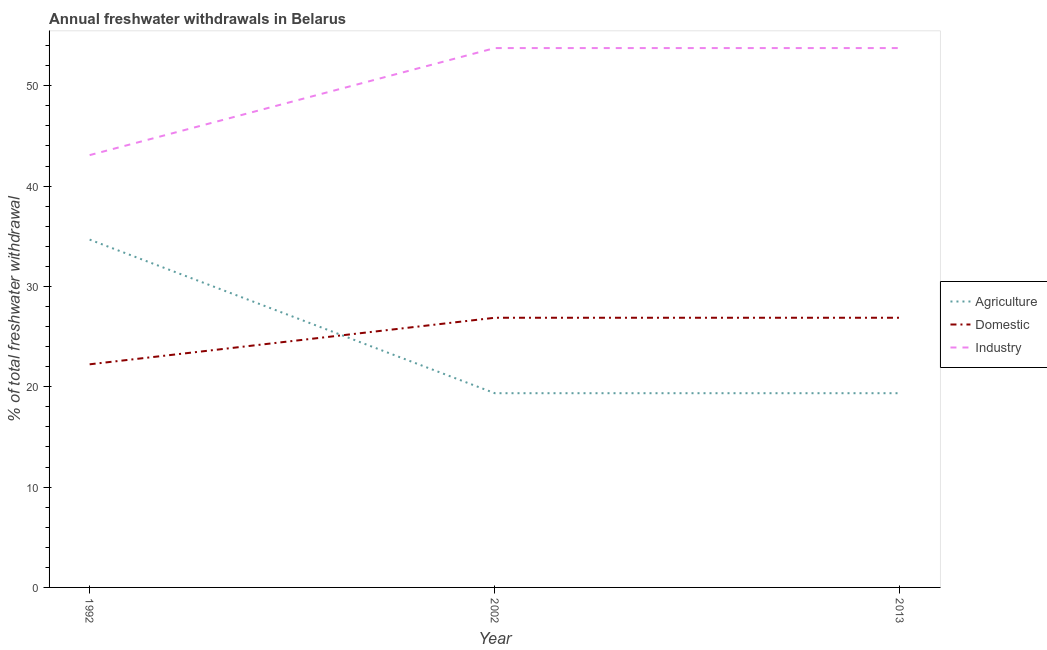How many different coloured lines are there?
Make the answer very short. 3. Does the line corresponding to percentage of freshwater withdrawal for industry intersect with the line corresponding to percentage of freshwater withdrawal for agriculture?
Provide a succinct answer. No. Is the number of lines equal to the number of legend labels?
Provide a short and direct response. Yes. What is the percentage of freshwater withdrawal for domestic purposes in 2002?
Your response must be concise. 26.88. Across all years, what is the maximum percentage of freshwater withdrawal for agriculture?
Ensure brevity in your answer.  34.67. Across all years, what is the minimum percentage of freshwater withdrawal for industry?
Offer a terse response. 43.09. What is the total percentage of freshwater withdrawal for domestic purposes in the graph?
Your response must be concise. 76. What is the difference between the percentage of freshwater withdrawal for industry in 1992 and that in 2002?
Provide a short and direct response. -10.67. What is the difference between the percentage of freshwater withdrawal for agriculture in 2013 and the percentage of freshwater withdrawal for domestic purposes in 2002?
Provide a short and direct response. -7.52. What is the average percentage of freshwater withdrawal for domestic purposes per year?
Provide a succinct answer. 25.33. In the year 1992, what is the difference between the percentage of freshwater withdrawal for domestic purposes and percentage of freshwater withdrawal for agriculture?
Provide a succinct answer. -12.43. In how many years, is the percentage of freshwater withdrawal for agriculture greater than 26 %?
Your response must be concise. 1. What is the ratio of the percentage of freshwater withdrawal for agriculture in 1992 to that in 2002?
Give a very brief answer. 1.79. Is the percentage of freshwater withdrawal for industry in 2002 less than that in 2013?
Give a very brief answer. No. What is the difference between the highest and the lowest percentage of freshwater withdrawal for agriculture?
Offer a very short reply. 15.31. In how many years, is the percentage of freshwater withdrawal for industry greater than the average percentage of freshwater withdrawal for industry taken over all years?
Your response must be concise. 2. Is the sum of the percentage of freshwater withdrawal for agriculture in 2002 and 2013 greater than the maximum percentage of freshwater withdrawal for industry across all years?
Ensure brevity in your answer.  No. Is the percentage of freshwater withdrawal for industry strictly less than the percentage of freshwater withdrawal for domestic purposes over the years?
Keep it short and to the point. No. How many years are there in the graph?
Your response must be concise. 3. Are the values on the major ticks of Y-axis written in scientific E-notation?
Provide a short and direct response. No. Does the graph contain grids?
Your response must be concise. No. How many legend labels are there?
Offer a very short reply. 3. What is the title of the graph?
Make the answer very short. Annual freshwater withdrawals in Belarus. Does "Argument" appear as one of the legend labels in the graph?
Offer a terse response. No. What is the label or title of the X-axis?
Your answer should be compact. Year. What is the label or title of the Y-axis?
Keep it short and to the point. % of total freshwater withdrawal. What is the % of total freshwater withdrawal in Agriculture in 1992?
Make the answer very short. 34.67. What is the % of total freshwater withdrawal of Domestic in 1992?
Ensure brevity in your answer.  22.24. What is the % of total freshwater withdrawal in Industry in 1992?
Offer a very short reply. 43.09. What is the % of total freshwater withdrawal in Agriculture in 2002?
Your answer should be compact. 19.36. What is the % of total freshwater withdrawal in Domestic in 2002?
Give a very brief answer. 26.88. What is the % of total freshwater withdrawal in Industry in 2002?
Make the answer very short. 53.76. What is the % of total freshwater withdrawal in Agriculture in 2013?
Your answer should be very brief. 19.36. What is the % of total freshwater withdrawal of Domestic in 2013?
Your answer should be very brief. 26.88. What is the % of total freshwater withdrawal in Industry in 2013?
Your answer should be very brief. 53.76. Across all years, what is the maximum % of total freshwater withdrawal of Agriculture?
Your answer should be very brief. 34.67. Across all years, what is the maximum % of total freshwater withdrawal in Domestic?
Offer a very short reply. 26.88. Across all years, what is the maximum % of total freshwater withdrawal in Industry?
Give a very brief answer. 53.76. Across all years, what is the minimum % of total freshwater withdrawal in Agriculture?
Provide a short and direct response. 19.36. Across all years, what is the minimum % of total freshwater withdrawal of Domestic?
Offer a terse response. 22.24. Across all years, what is the minimum % of total freshwater withdrawal of Industry?
Your answer should be compact. 43.09. What is the total % of total freshwater withdrawal of Agriculture in the graph?
Ensure brevity in your answer.  73.39. What is the total % of total freshwater withdrawal in Industry in the graph?
Make the answer very short. 150.61. What is the difference between the % of total freshwater withdrawal in Agriculture in 1992 and that in 2002?
Your answer should be compact. 15.31. What is the difference between the % of total freshwater withdrawal of Domestic in 1992 and that in 2002?
Offer a very short reply. -4.64. What is the difference between the % of total freshwater withdrawal in Industry in 1992 and that in 2002?
Your response must be concise. -10.67. What is the difference between the % of total freshwater withdrawal of Agriculture in 1992 and that in 2013?
Your answer should be very brief. 15.31. What is the difference between the % of total freshwater withdrawal in Domestic in 1992 and that in 2013?
Provide a succinct answer. -4.64. What is the difference between the % of total freshwater withdrawal in Industry in 1992 and that in 2013?
Offer a terse response. -10.67. What is the difference between the % of total freshwater withdrawal of Agriculture in 2002 and that in 2013?
Give a very brief answer. 0. What is the difference between the % of total freshwater withdrawal in Industry in 2002 and that in 2013?
Offer a very short reply. 0. What is the difference between the % of total freshwater withdrawal of Agriculture in 1992 and the % of total freshwater withdrawal of Domestic in 2002?
Give a very brief answer. 7.79. What is the difference between the % of total freshwater withdrawal in Agriculture in 1992 and the % of total freshwater withdrawal in Industry in 2002?
Your answer should be very brief. -19.09. What is the difference between the % of total freshwater withdrawal in Domestic in 1992 and the % of total freshwater withdrawal in Industry in 2002?
Provide a succinct answer. -31.52. What is the difference between the % of total freshwater withdrawal in Agriculture in 1992 and the % of total freshwater withdrawal in Domestic in 2013?
Give a very brief answer. 7.79. What is the difference between the % of total freshwater withdrawal in Agriculture in 1992 and the % of total freshwater withdrawal in Industry in 2013?
Offer a very short reply. -19.09. What is the difference between the % of total freshwater withdrawal of Domestic in 1992 and the % of total freshwater withdrawal of Industry in 2013?
Offer a terse response. -31.52. What is the difference between the % of total freshwater withdrawal of Agriculture in 2002 and the % of total freshwater withdrawal of Domestic in 2013?
Your response must be concise. -7.52. What is the difference between the % of total freshwater withdrawal in Agriculture in 2002 and the % of total freshwater withdrawal in Industry in 2013?
Your response must be concise. -34.4. What is the difference between the % of total freshwater withdrawal in Domestic in 2002 and the % of total freshwater withdrawal in Industry in 2013?
Your answer should be compact. -26.88. What is the average % of total freshwater withdrawal in Agriculture per year?
Provide a succinct answer. 24.46. What is the average % of total freshwater withdrawal in Domestic per year?
Your response must be concise. 25.33. What is the average % of total freshwater withdrawal in Industry per year?
Give a very brief answer. 50.2. In the year 1992, what is the difference between the % of total freshwater withdrawal in Agriculture and % of total freshwater withdrawal in Domestic?
Your response must be concise. 12.43. In the year 1992, what is the difference between the % of total freshwater withdrawal in Agriculture and % of total freshwater withdrawal in Industry?
Provide a short and direct response. -8.42. In the year 1992, what is the difference between the % of total freshwater withdrawal of Domestic and % of total freshwater withdrawal of Industry?
Provide a succinct answer. -20.85. In the year 2002, what is the difference between the % of total freshwater withdrawal of Agriculture and % of total freshwater withdrawal of Domestic?
Offer a terse response. -7.52. In the year 2002, what is the difference between the % of total freshwater withdrawal in Agriculture and % of total freshwater withdrawal in Industry?
Offer a very short reply. -34.4. In the year 2002, what is the difference between the % of total freshwater withdrawal of Domestic and % of total freshwater withdrawal of Industry?
Offer a terse response. -26.88. In the year 2013, what is the difference between the % of total freshwater withdrawal in Agriculture and % of total freshwater withdrawal in Domestic?
Give a very brief answer. -7.52. In the year 2013, what is the difference between the % of total freshwater withdrawal in Agriculture and % of total freshwater withdrawal in Industry?
Provide a short and direct response. -34.4. In the year 2013, what is the difference between the % of total freshwater withdrawal of Domestic and % of total freshwater withdrawal of Industry?
Keep it short and to the point. -26.88. What is the ratio of the % of total freshwater withdrawal in Agriculture in 1992 to that in 2002?
Offer a very short reply. 1.79. What is the ratio of the % of total freshwater withdrawal of Domestic in 1992 to that in 2002?
Your answer should be very brief. 0.83. What is the ratio of the % of total freshwater withdrawal of Industry in 1992 to that in 2002?
Give a very brief answer. 0.8. What is the ratio of the % of total freshwater withdrawal in Agriculture in 1992 to that in 2013?
Your response must be concise. 1.79. What is the ratio of the % of total freshwater withdrawal in Domestic in 1992 to that in 2013?
Ensure brevity in your answer.  0.83. What is the ratio of the % of total freshwater withdrawal of Industry in 1992 to that in 2013?
Keep it short and to the point. 0.8. What is the ratio of the % of total freshwater withdrawal of Industry in 2002 to that in 2013?
Keep it short and to the point. 1. What is the difference between the highest and the second highest % of total freshwater withdrawal of Agriculture?
Provide a short and direct response. 15.31. What is the difference between the highest and the second highest % of total freshwater withdrawal of Industry?
Make the answer very short. 0. What is the difference between the highest and the lowest % of total freshwater withdrawal in Agriculture?
Your response must be concise. 15.31. What is the difference between the highest and the lowest % of total freshwater withdrawal of Domestic?
Give a very brief answer. 4.64. What is the difference between the highest and the lowest % of total freshwater withdrawal in Industry?
Ensure brevity in your answer.  10.67. 